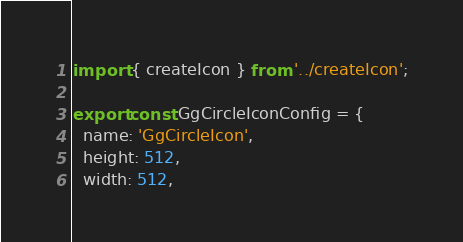<code> <loc_0><loc_0><loc_500><loc_500><_JavaScript_>import { createIcon } from '../createIcon';

export const GgCircleIconConfig = {
  name: 'GgCircleIcon',
  height: 512,
  width: 512,</code> 